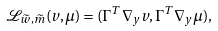Convert formula to latex. <formula><loc_0><loc_0><loc_500><loc_500>\mathcal { L } _ { \widetilde { w } , \widetilde { m } } ( v , \mu ) = ( \Gamma ^ { T } \nabla _ { y } v , \Gamma ^ { T } \nabla _ { y } \mu ) ,</formula> 